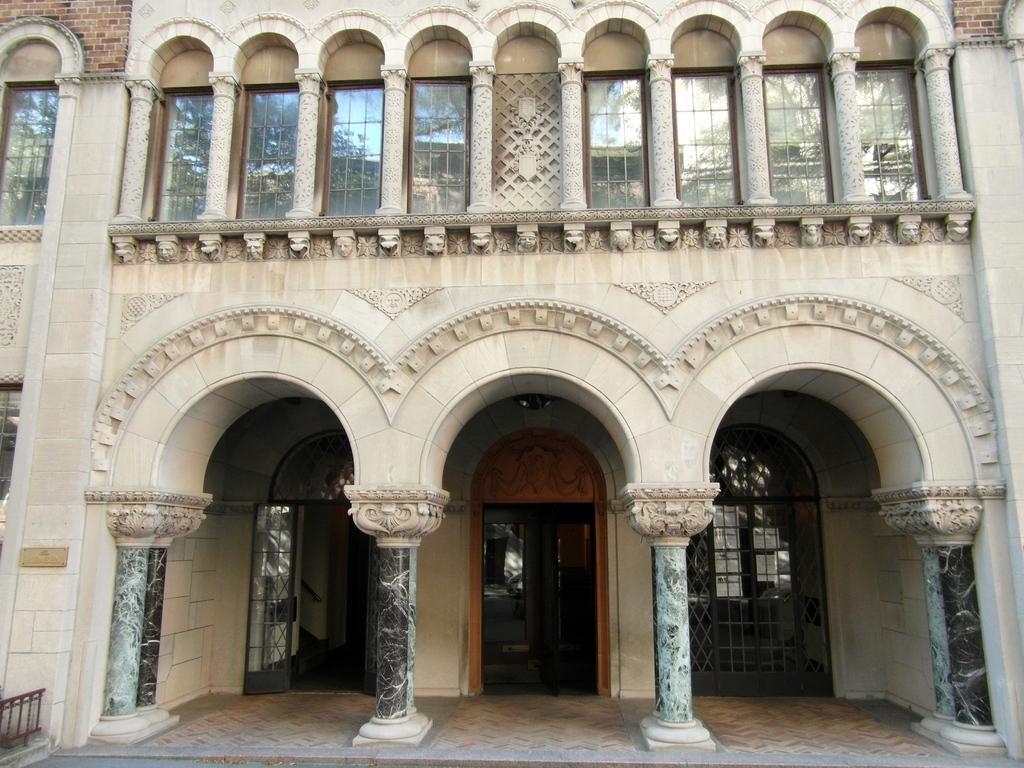In one or two sentences, can you explain what this image depicts? In the center of the image there is a building. There is a door. There are pillars. There are windows. 